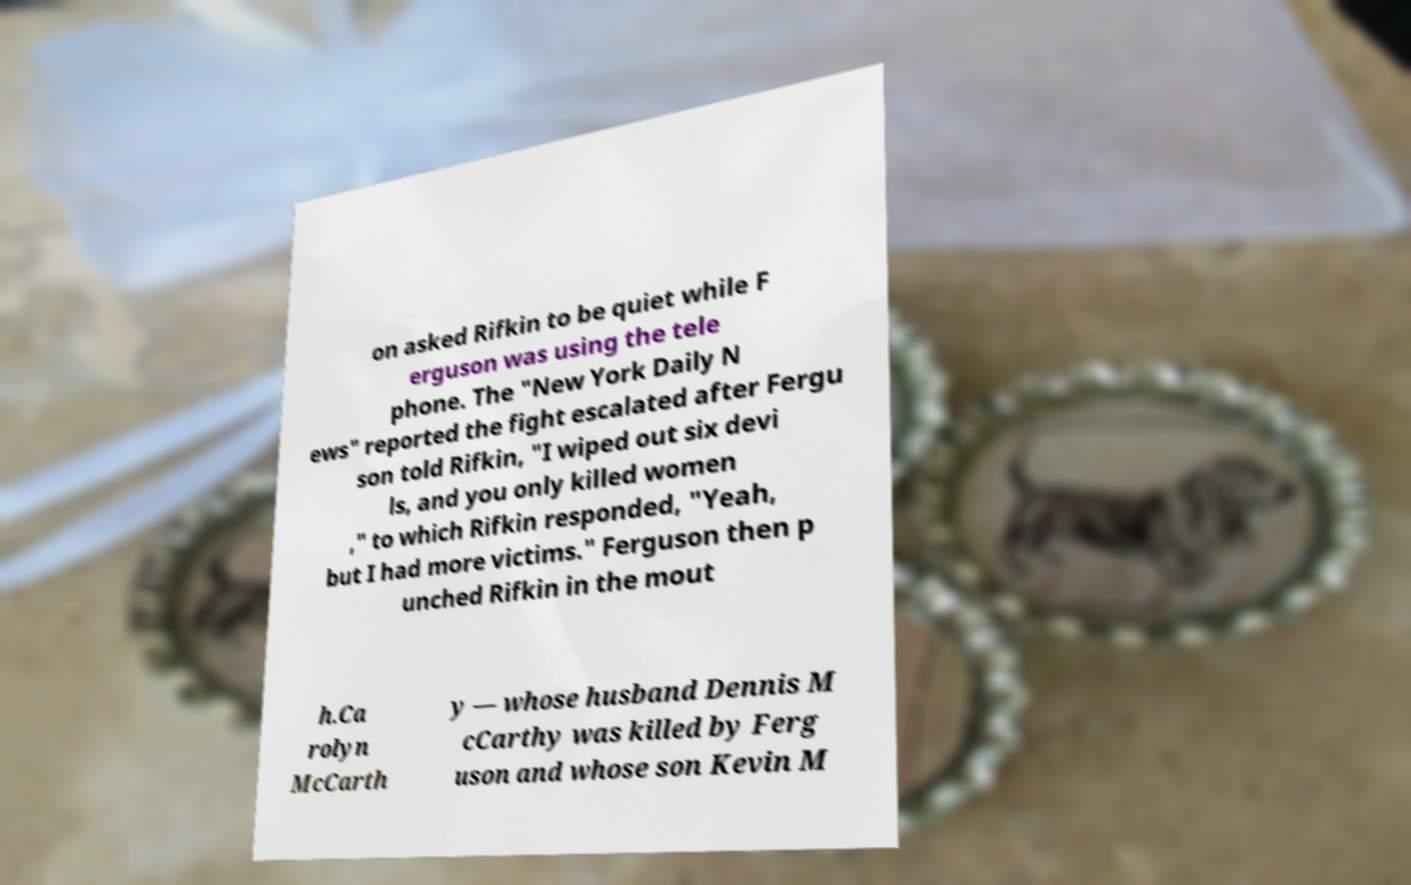Can you read and provide the text displayed in the image?This photo seems to have some interesting text. Can you extract and type it out for me? on asked Rifkin to be quiet while F erguson was using the tele phone. The "New York Daily N ews" reported the fight escalated after Fergu son told Rifkin, "I wiped out six devi ls, and you only killed women ," to which Rifkin responded, "Yeah, but I had more victims." Ferguson then p unched Rifkin in the mout h.Ca rolyn McCarth y — whose husband Dennis M cCarthy was killed by Ferg uson and whose son Kevin M 